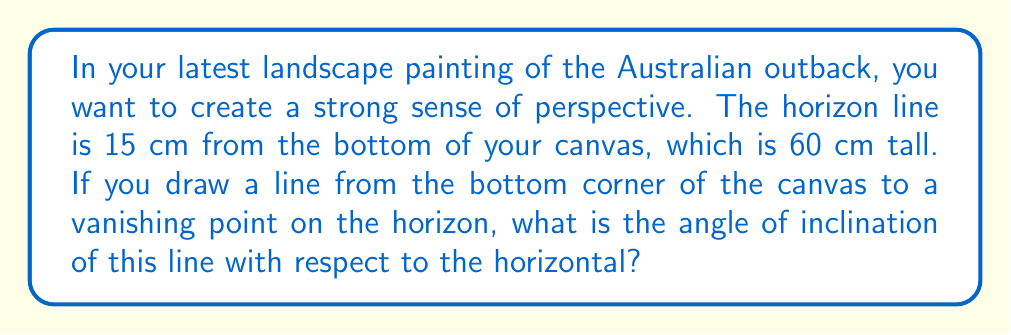Provide a solution to this math problem. Let's approach this step-by-step:

1) First, we need to visualize the problem. We have a right triangle where:
   - The base is half the width of the canvas (since the vanishing point is typically in the center of the horizon)
   - The height is the distance from the bottom of the canvas to the horizon (15 cm)
   - The hypotenuse is the line we're drawing to create perspective

2) We can represent this situation with the following diagram:

[asy]
unitsize(1cm);
pair A=(0,0), B=(4,0), C=(4,1);
draw(A--B--C--A);
label("15 cm", (4,0.5), E);
label("30 cm", (2,0), S);
label("θ", (0.3,0.2), NW);
[/asy]

3) To find the angle of inclination (θ), we can use the tangent function:

   $$\tan(\theta) = \frac{\text{opposite}}{\text{adjacent}} = \frac{15 \text{ cm}}{30 \text{ cm}} = \frac{1}{2}$$

4) To find θ, we need to take the inverse tangent (arctan or tan^(-1)):

   $$\theta = \tan^{-1}(\frac{1}{2})$$

5) Using a calculator or mathematical tables:

   $$\theta \approx 26.57°$$

This angle will create a strong sense of perspective in your Australian outback landscape painting.
Answer: $26.57°$ 